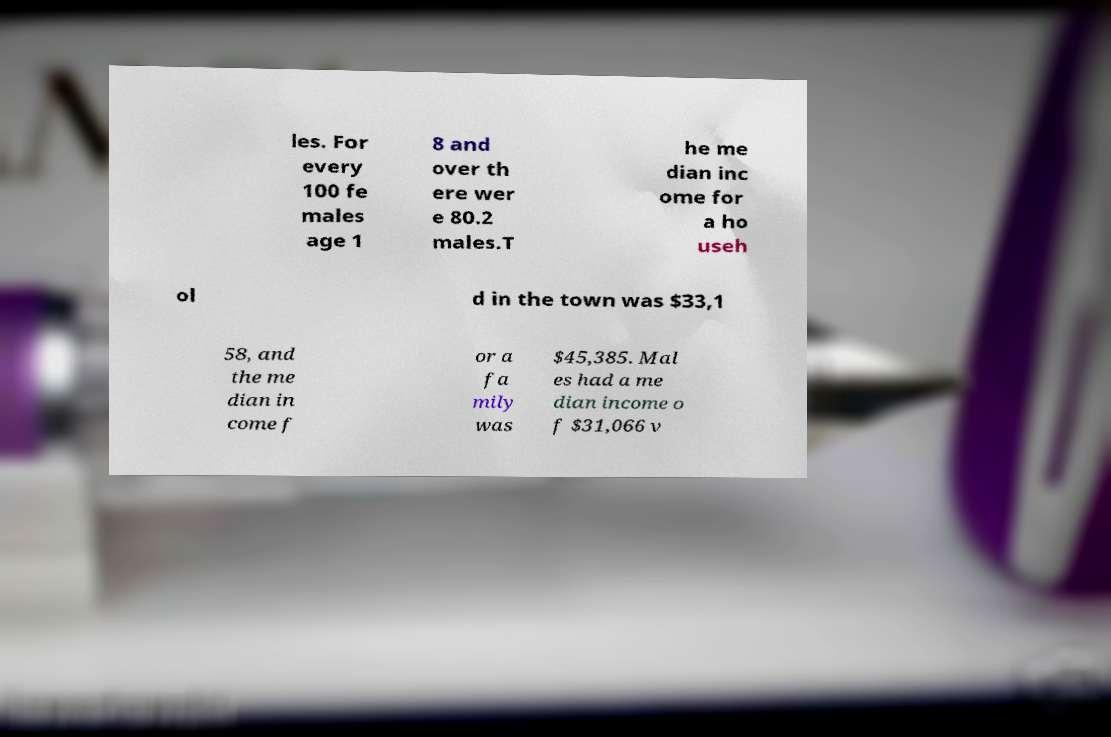There's text embedded in this image that I need extracted. Can you transcribe it verbatim? les. For every 100 fe males age 1 8 and over th ere wer e 80.2 males.T he me dian inc ome for a ho useh ol d in the town was $33,1 58, and the me dian in come f or a fa mily was $45,385. Mal es had a me dian income o f $31,066 v 